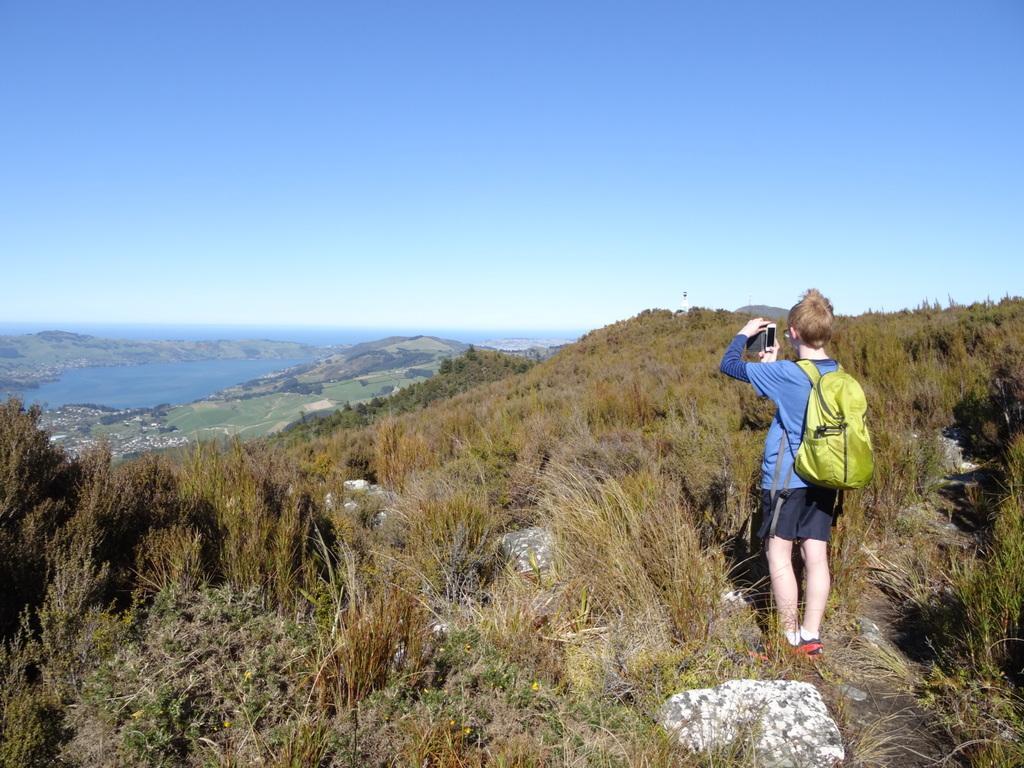Describe this image in one or two sentences. It's A sunny day. A person is standing and taking pictures from his mobile, he is carrying a backpack and wearing shoes. The sky is clear and mountains and water is present, he is surrounded by the grass. 